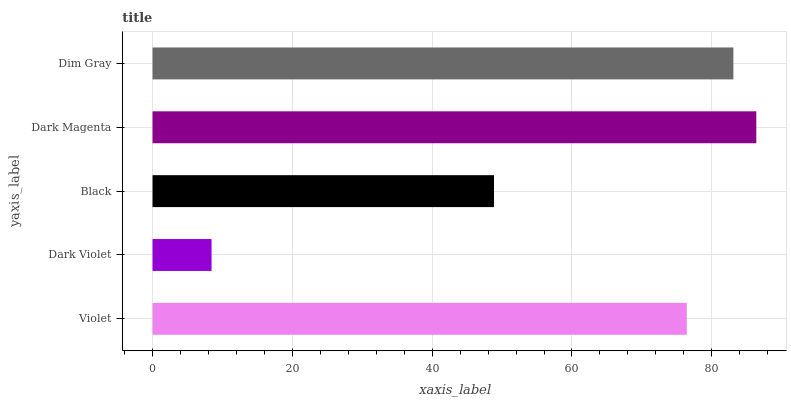Is Dark Violet the minimum?
Answer yes or no. Yes. Is Dark Magenta the maximum?
Answer yes or no. Yes. Is Black the minimum?
Answer yes or no. No. Is Black the maximum?
Answer yes or no. No. Is Black greater than Dark Violet?
Answer yes or no. Yes. Is Dark Violet less than Black?
Answer yes or no. Yes. Is Dark Violet greater than Black?
Answer yes or no. No. Is Black less than Dark Violet?
Answer yes or no. No. Is Violet the high median?
Answer yes or no. Yes. Is Violet the low median?
Answer yes or no. Yes. Is Black the high median?
Answer yes or no. No. Is Dark Magenta the low median?
Answer yes or no. No. 